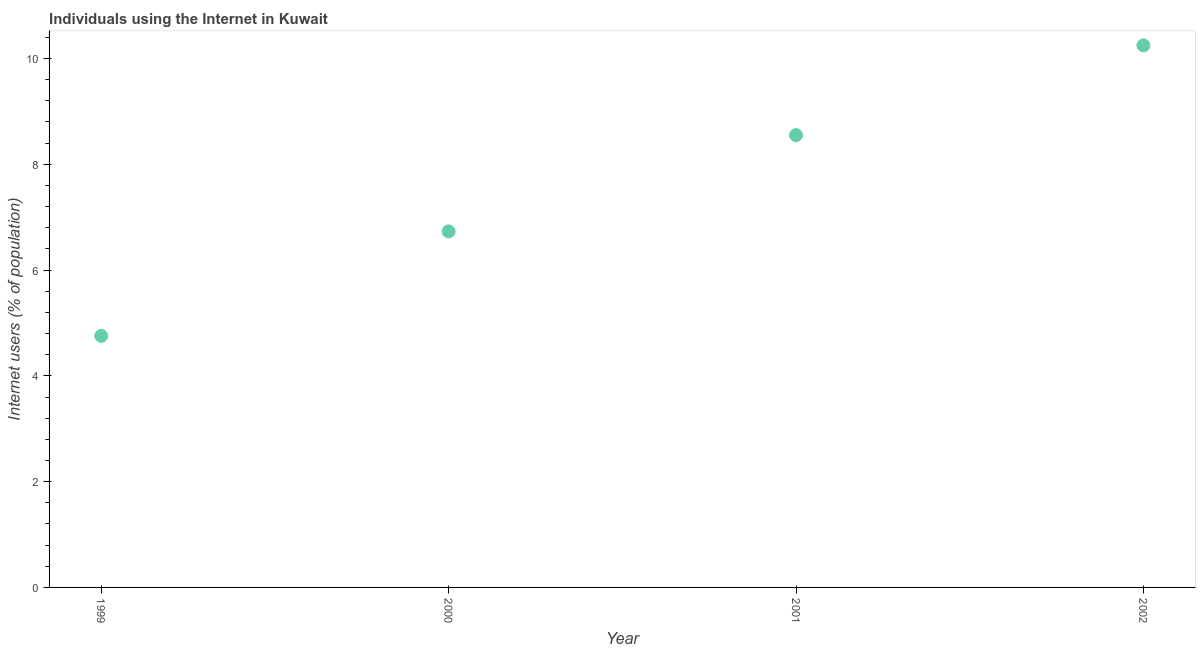What is the number of internet users in 2000?
Make the answer very short. 6.73. Across all years, what is the maximum number of internet users?
Keep it short and to the point. 10.25. Across all years, what is the minimum number of internet users?
Keep it short and to the point. 4.76. In which year was the number of internet users minimum?
Ensure brevity in your answer.  1999. What is the sum of the number of internet users?
Offer a terse response. 30.29. What is the difference between the number of internet users in 1999 and 2002?
Make the answer very short. -5.49. What is the average number of internet users per year?
Keep it short and to the point. 7.57. What is the median number of internet users?
Give a very brief answer. 7.64. In how many years, is the number of internet users greater than 5.6 %?
Give a very brief answer. 3. What is the ratio of the number of internet users in 2000 to that in 2001?
Provide a succinct answer. 0.79. Is the number of internet users in 1999 less than that in 2000?
Keep it short and to the point. Yes. Is the difference between the number of internet users in 2000 and 2002 greater than the difference between any two years?
Provide a succinct answer. No. What is the difference between the highest and the second highest number of internet users?
Make the answer very short. 1.7. Is the sum of the number of internet users in 2000 and 2002 greater than the maximum number of internet users across all years?
Provide a short and direct response. Yes. What is the difference between the highest and the lowest number of internet users?
Your answer should be compact. 5.49. How many dotlines are there?
Your answer should be compact. 1. Does the graph contain any zero values?
Provide a succinct answer. No. Does the graph contain grids?
Give a very brief answer. No. What is the title of the graph?
Offer a very short reply. Individuals using the Internet in Kuwait. What is the label or title of the Y-axis?
Keep it short and to the point. Internet users (% of population). What is the Internet users (% of population) in 1999?
Your answer should be very brief. 4.76. What is the Internet users (% of population) in 2000?
Offer a terse response. 6.73. What is the Internet users (% of population) in 2001?
Offer a very short reply. 8.55. What is the Internet users (% of population) in 2002?
Provide a short and direct response. 10.25. What is the difference between the Internet users (% of population) in 1999 and 2000?
Your answer should be compact. -1.98. What is the difference between the Internet users (% of population) in 1999 and 2001?
Give a very brief answer. -3.8. What is the difference between the Internet users (% of population) in 1999 and 2002?
Your answer should be compact. -5.49. What is the difference between the Internet users (% of population) in 2000 and 2001?
Make the answer very short. -1.82. What is the difference between the Internet users (% of population) in 2000 and 2002?
Offer a very short reply. -3.52. What is the difference between the Internet users (% of population) in 2001 and 2002?
Make the answer very short. -1.7. What is the ratio of the Internet users (% of population) in 1999 to that in 2000?
Your answer should be compact. 0.71. What is the ratio of the Internet users (% of population) in 1999 to that in 2001?
Give a very brief answer. 0.56. What is the ratio of the Internet users (% of population) in 1999 to that in 2002?
Provide a short and direct response. 0.46. What is the ratio of the Internet users (% of population) in 2000 to that in 2001?
Keep it short and to the point. 0.79. What is the ratio of the Internet users (% of population) in 2000 to that in 2002?
Provide a short and direct response. 0.66. What is the ratio of the Internet users (% of population) in 2001 to that in 2002?
Provide a short and direct response. 0.83. 